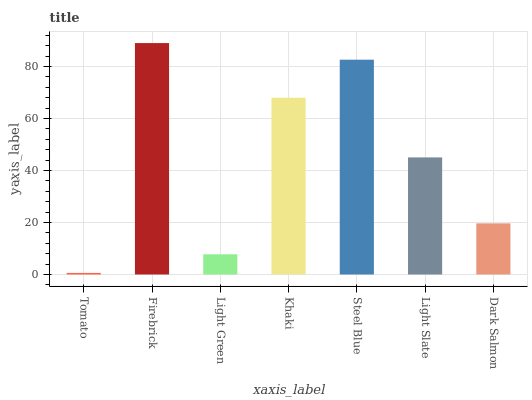Is Tomato the minimum?
Answer yes or no. Yes. Is Firebrick the maximum?
Answer yes or no. Yes. Is Light Green the minimum?
Answer yes or no. No. Is Light Green the maximum?
Answer yes or no. No. Is Firebrick greater than Light Green?
Answer yes or no. Yes. Is Light Green less than Firebrick?
Answer yes or no. Yes. Is Light Green greater than Firebrick?
Answer yes or no. No. Is Firebrick less than Light Green?
Answer yes or no. No. Is Light Slate the high median?
Answer yes or no. Yes. Is Light Slate the low median?
Answer yes or no. Yes. Is Dark Salmon the high median?
Answer yes or no. No. Is Light Green the low median?
Answer yes or no. No. 